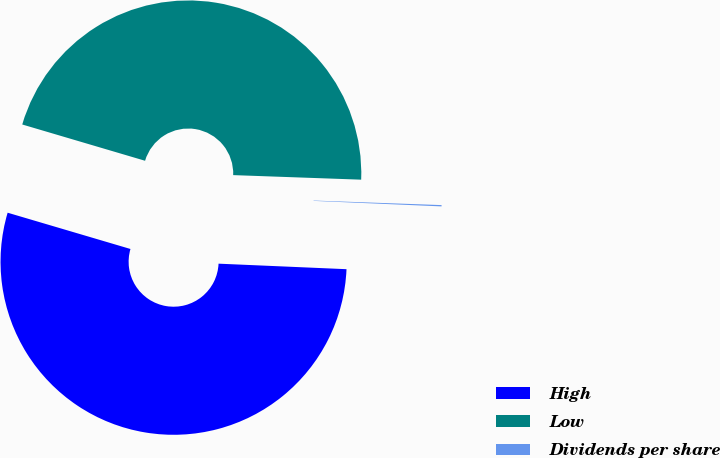Convert chart. <chart><loc_0><loc_0><loc_500><loc_500><pie_chart><fcel>High<fcel>Low<fcel>Dividends per share<nl><fcel>53.89%<fcel>46.0%<fcel>0.12%<nl></chart> 